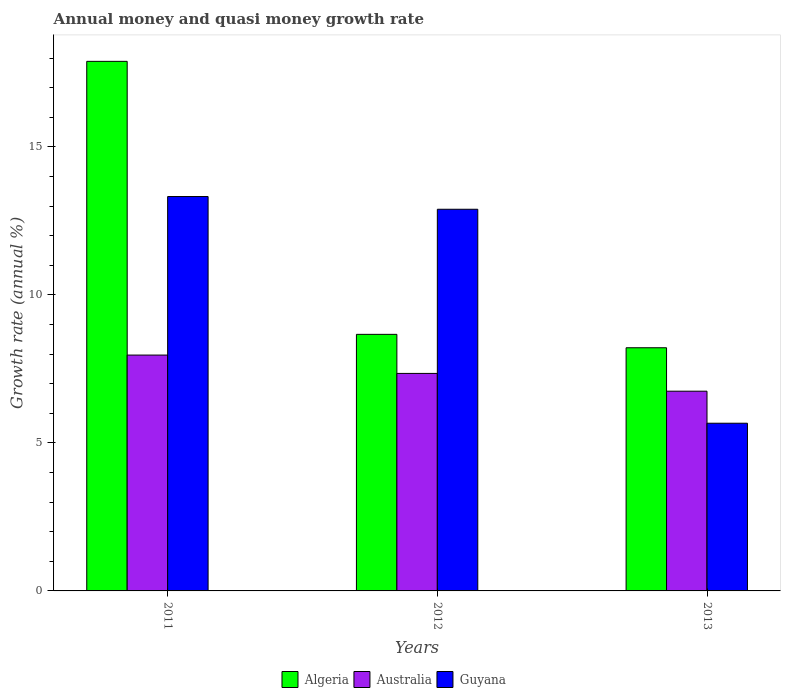How many different coloured bars are there?
Give a very brief answer. 3. How many groups of bars are there?
Offer a very short reply. 3. Are the number of bars per tick equal to the number of legend labels?
Provide a short and direct response. Yes. Are the number of bars on each tick of the X-axis equal?
Offer a terse response. Yes. How many bars are there on the 2nd tick from the left?
Make the answer very short. 3. How many bars are there on the 3rd tick from the right?
Give a very brief answer. 3. In how many cases, is the number of bars for a given year not equal to the number of legend labels?
Your answer should be compact. 0. What is the growth rate in Guyana in 2013?
Offer a terse response. 5.67. Across all years, what is the maximum growth rate in Algeria?
Your answer should be compact. 17.89. Across all years, what is the minimum growth rate in Algeria?
Your response must be concise. 8.22. In which year was the growth rate in Algeria maximum?
Your answer should be compact. 2011. In which year was the growth rate in Guyana minimum?
Keep it short and to the point. 2013. What is the total growth rate in Algeria in the graph?
Your answer should be compact. 34.77. What is the difference between the growth rate in Guyana in 2012 and that in 2013?
Your answer should be very brief. 7.23. What is the difference between the growth rate in Algeria in 2011 and the growth rate in Australia in 2013?
Ensure brevity in your answer.  11.14. What is the average growth rate in Australia per year?
Offer a very short reply. 7.35. In the year 2013, what is the difference between the growth rate in Australia and growth rate in Guyana?
Provide a succinct answer. 1.08. What is the ratio of the growth rate in Algeria in 2012 to that in 2013?
Keep it short and to the point. 1.06. Is the growth rate in Algeria in 2011 less than that in 2013?
Provide a short and direct response. No. Is the difference between the growth rate in Australia in 2011 and 2013 greater than the difference between the growth rate in Guyana in 2011 and 2013?
Give a very brief answer. No. What is the difference between the highest and the second highest growth rate in Australia?
Offer a very short reply. 0.62. What is the difference between the highest and the lowest growth rate in Guyana?
Your answer should be compact. 7.66. In how many years, is the growth rate in Guyana greater than the average growth rate in Guyana taken over all years?
Your answer should be very brief. 2. Is the sum of the growth rate in Australia in 2011 and 2012 greater than the maximum growth rate in Algeria across all years?
Provide a short and direct response. No. What does the 1st bar from the left in 2012 represents?
Give a very brief answer. Algeria. What does the 3rd bar from the right in 2011 represents?
Give a very brief answer. Algeria. How many bars are there?
Your answer should be very brief. 9. Are all the bars in the graph horizontal?
Give a very brief answer. No. Does the graph contain any zero values?
Give a very brief answer. No. Does the graph contain grids?
Your response must be concise. No. What is the title of the graph?
Provide a succinct answer. Annual money and quasi money growth rate. Does "Seychelles" appear as one of the legend labels in the graph?
Provide a succinct answer. No. What is the label or title of the X-axis?
Your response must be concise. Years. What is the label or title of the Y-axis?
Your response must be concise. Growth rate (annual %). What is the Growth rate (annual %) in Algeria in 2011?
Provide a short and direct response. 17.89. What is the Growth rate (annual %) in Australia in 2011?
Your answer should be compact. 7.97. What is the Growth rate (annual %) in Guyana in 2011?
Offer a terse response. 13.32. What is the Growth rate (annual %) of Algeria in 2012?
Offer a very short reply. 8.67. What is the Growth rate (annual %) of Australia in 2012?
Your answer should be compact. 7.35. What is the Growth rate (annual %) in Guyana in 2012?
Your answer should be compact. 12.89. What is the Growth rate (annual %) in Algeria in 2013?
Provide a short and direct response. 8.22. What is the Growth rate (annual %) of Australia in 2013?
Provide a succinct answer. 6.75. What is the Growth rate (annual %) in Guyana in 2013?
Ensure brevity in your answer.  5.67. Across all years, what is the maximum Growth rate (annual %) in Algeria?
Provide a succinct answer. 17.89. Across all years, what is the maximum Growth rate (annual %) of Australia?
Offer a terse response. 7.97. Across all years, what is the maximum Growth rate (annual %) of Guyana?
Give a very brief answer. 13.32. Across all years, what is the minimum Growth rate (annual %) of Algeria?
Keep it short and to the point. 8.22. Across all years, what is the minimum Growth rate (annual %) of Australia?
Offer a very short reply. 6.75. Across all years, what is the minimum Growth rate (annual %) in Guyana?
Your answer should be very brief. 5.67. What is the total Growth rate (annual %) in Algeria in the graph?
Provide a succinct answer. 34.77. What is the total Growth rate (annual %) in Australia in the graph?
Offer a very short reply. 22.06. What is the total Growth rate (annual %) in Guyana in the graph?
Provide a succinct answer. 31.88. What is the difference between the Growth rate (annual %) in Algeria in 2011 and that in 2012?
Ensure brevity in your answer.  9.22. What is the difference between the Growth rate (annual %) of Australia in 2011 and that in 2012?
Provide a short and direct response. 0.62. What is the difference between the Growth rate (annual %) in Guyana in 2011 and that in 2012?
Give a very brief answer. 0.43. What is the difference between the Growth rate (annual %) of Algeria in 2011 and that in 2013?
Offer a very short reply. 9.68. What is the difference between the Growth rate (annual %) of Australia in 2011 and that in 2013?
Provide a succinct answer. 1.22. What is the difference between the Growth rate (annual %) of Guyana in 2011 and that in 2013?
Offer a very short reply. 7.66. What is the difference between the Growth rate (annual %) in Algeria in 2012 and that in 2013?
Your answer should be very brief. 0.45. What is the difference between the Growth rate (annual %) of Australia in 2012 and that in 2013?
Provide a succinct answer. 0.6. What is the difference between the Growth rate (annual %) of Guyana in 2012 and that in 2013?
Offer a terse response. 7.23. What is the difference between the Growth rate (annual %) in Algeria in 2011 and the Growth rate (annual %) in Australia in 2012?
Ensure brevity in your answer.  10.54. What is the difference between the Growth rate (annual %) of Algeria in 2011 and the Growth rate (annual %) of Guyana in 2012?
Your answer should be very brief. 5. What is the difference between the Growth rate (annual %) of Australia in 2011 and the Growth rate (annual %) of Guyana in 2012?
Your response must be concise. -4.93. What is the difference between the Growth rate (annual %) in Algeria in 2011 and the Growth rate (annual %) in Australia in 2013?
Give a very brief answer. 11.14. What is the difference between the Growth rate (annual %) of Algeria in 2011 and the Growth rate (annual %) of Guyana in 2013?
Offer a terse response. 12.23. What is the difference between the Growth rate (annual %) in Australia in 2011 and the Growth rate (annual %) in Guyana in 2013?
Your answer should be very brief. 2.3. What is the difference between the Growth rate (annual %) in Algeria in 2012 and the Growth rate (annual %) in Australia in 2013?
Make the answer very short. 1.92. What is the difference between the Growth rate (annual %) of Algeria in 2012 and the Growth rate (annual %) of Guyana in 2013?
Provide a succinct answer. 3. What is the difference between the Growth rate (annual %) in Australia in 2012 and the Growth rate (annual %) in Guyana in 2013?
Give a very brief answer. 1.68. What is the average Growth rate (annual %) of Algeria per year?
Your answer should be very brief. 11.59. What is the average Growth rate (annual %) in Australia per year?
Your response must be concise. 7.35. What is the average Growth rate (annual %) of Guyana per year?
Provide a short and direct response. 10.63. In the year 2011, what is the difference between the Growth rate (annual %) in Algeria and Growth rate (annual %) in Australia?
Ensure brevity in your answer.  9.92. In the year 2011, what is the difference between the Growth rate (annual %) of Algeria and Growth rate (annual %) of Guyana?
Provide a short and direct response. 4.57. In the year 2011, what is the difference between the Growth rate (annual %) of Australia and Growth rate (annual %) of Guyana?
Offer a very short reply. -5.36. In the year 2012, what is the difference between the Growth rate (annual %) of Algeria and Growth rate (annual %) of Australia?
Ensure brevity in your answer.  1.32. In the year 2012, what is the difference between the Growth rate (annual %) in Algeria and Growth rate (annual %) in Guyana?
Offer a terse response. -4.23. In the year 2012, what is the difference between the Growth rate (annual %) of Australia and Growth rate (annual %) of Guyana?
Your answer should be very brief. -5.55. In the year 2013, what is the difference between the Growth rate (annual %) of Algeria and Growth rate (annual %) of Australia?
Offer a very short reply. 1.47. In the year 2013, what is the difference between the Growth rate (annual %) of Algeria and Growth rate (annual %) of Guyana?
Make the answer very short. 2.55. In the year 2013, what is the difference between the Growth rate (annual %) in Australia and Growth rate (annual %) in Guyana?
Offer a very short reply. 1.08. What is the ratio of the Growth rate (annual %) in Algeria in 2011 to that in 2012?
Your answer should be compact. 2.06. What is the ratio of the Growth rate (annual %) of Australia in 2011 to that in 2012?
Ensure brevity in your answer.  1.08. What is the ratio of the Growth rate (annual %) of Algeria in 2011 to that in 2013?
Your answer should be very brief. 2.18. What is the ratio of the Growth rate (annual %) in Australia in 2011 to that in 2013?
Your answer should be compact. 1.18. What is the ratio of the Growth rate (annual %) in Guyana in 2011 to that in 2013?
Provide a succinct answer. 2.35. What is the ratio of the Growth rate (annual %) of Algeria in 2012 to that in 2013?
Ensure brevity in your answer.  1.06. What is the ratio of the Growth rate (annual %) in Australia in 2012 to that in 2013?
Your answer should be compact. 1.09. What is the ratio of the Growth rate (annual %) in Guyana in 2012 to that in 2013?
Keep it short and to the point. 2.28. What is the difference between the highest and the second highest Growth rate (annual %) in Algeria?
Offer a terse response. 9.22. What is the difference between the highest and the second highest Growth rate (annual %) in Australia?
Your answer should be compact. 0.62. What is the difference between the highest and the second highest Growth rate (annual %) of Guyana?
Offer a terse response. 0.43. What is the difference between the highest and the lowest Growth rate (annual %) in Algeria?
Provide a short and direct response. 9.68. What is the difference between the highest and the lowest Growth rate (annual %) in Australia?
Your answer should be compact. 1.22. What is the difference between the highest and the lowest Growth rate (annual %) of Guyana?
Your answer should be very brief. 7.66. 